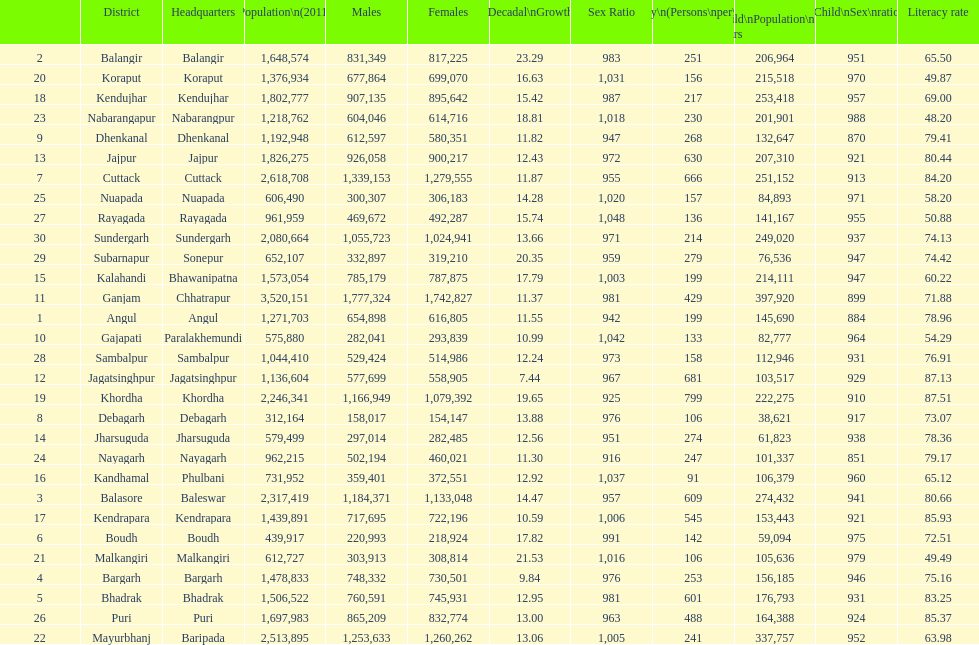What is the number of districts with percentage decadal growth above 15% 10. 